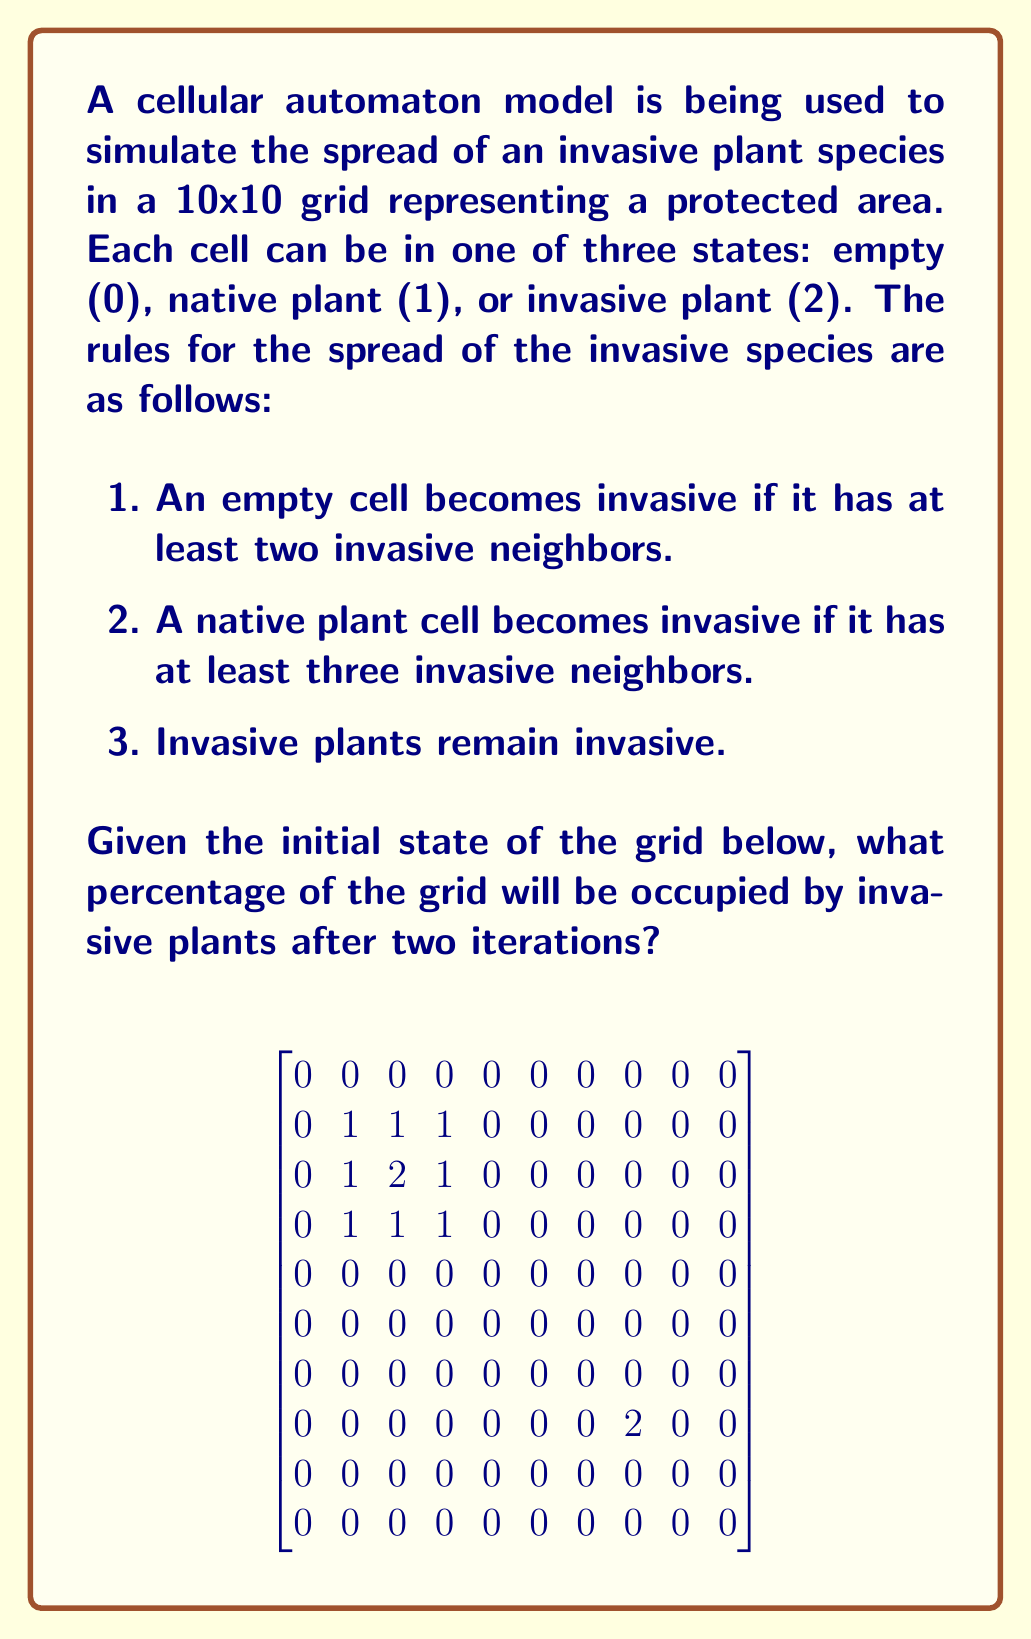Help me with this question. Let's approach this step-by-step:

1) First iteration:
   - The invasive plant at (2,2) will cause the native plants at (1,2), (2,1), (2,3), and (3,2) to become invasive.
   - The invasive plant at (7,7) will not spread in this iteration.

   After the first iteration, the grid looks like this:
   $$
   \begin{bmatrix}
   0 & 0 & 0 & 0 & 0 & 0 & 0 & 0 & 0 & 0 \\
   0 & 1 & 2 & 1 & 0 & 0 & 0 & 0 & 0 & 0 \\
   0 & 2 & 2 & 2 & 0 & 0 & 0 & 0 & 0 & 0 \\
   0 & 1 & 2 & 1 & 0 & 0 & 0 & 0 & 0 & 0 \\
   0 & 0 & 0 & 0 & 0 & 0 & 0 & 0 & 0 & 0 \\
   0 & 0 & 0 & 0 & 0 & 0 & 0 & 0 & 0 & 0 \\
   0 & 0 & 0 & 0 & 0 & 0 & 0 & 0 & 0 & 0 \\
   0 & 0 & 0 & 0 & 0 & 0 & 0 & 2 & 0 & 0 \\
   0 & 0 & 0 & 0 & 0 & 0 & 0 & 0 & 0 & 0 \\
   0 & 0 & 0 & 0 & 0 & 0 & 0 & 0 & 0 & 0
   \end{bmatrix}
   $$

2) Second iteration:
   - The invasive plants at (1,2), (2,1), (2,2), (2,3), and (3,2) will cause the empty cells at (1,1), (1,3), (3,1), and (3,3) to become invasive.
   - The native plants at (1,1) and (1,3) will also become invasive.
   - The invasive plant at (7,7) will still not spread.

   After the second iteration, the grid looks like this:
   $$
   \begin{bmatrix}
   0 & 0 & 0 & 0 & 0 & 0 & 0 & 0 & 0 & 0 \\
   2 & 2 & 2 & 2 & 0 & 0 & 0 & 0 & 0 & 0 \\
   2 & 2 & 2 & 2 & 0 & 0 & 0 & 0 & 0 & 0 \\
   2 & 2 & 2 & 2 & 0 & 0 & 0 & 0 & 0 & 0 \\
   0 & 0 & 0 & 0 & 0 & 0 & 0 & 0 & 0 & 0 \\
   0 & 0 & 0 & 0 & 0 & 0 & 0 & 0 & 0 & 0 \\
   0 & 0 & 0 & 0 & 0 & 0 & 0 & 0 & 0 & 0 \\
   0 & 0 & 0 & 0 & 0 & 0 & 0 & 2 & 0 & 0 \\
   0 & 0 & 0 & 0 & 0 & 0 & 0 & 0 & 0 & 0 \\
   0 & 0 & 0 & 0 & 0 & 0 & 0 & 0 & 0 & 0
   \end{bmatrix}
   $$

3) Counting invasive plants:
   - There are 13 cells with invasive plants (2).
   - The total number of cells is 100 (10x10 grid).

4) Calculating the percentage:
   $\frac{13}{100} \times 100\% = 13\%$

Therefore, after two iterations, 13% of the grid will be occupied by invasive plants.
Answer: 13% 